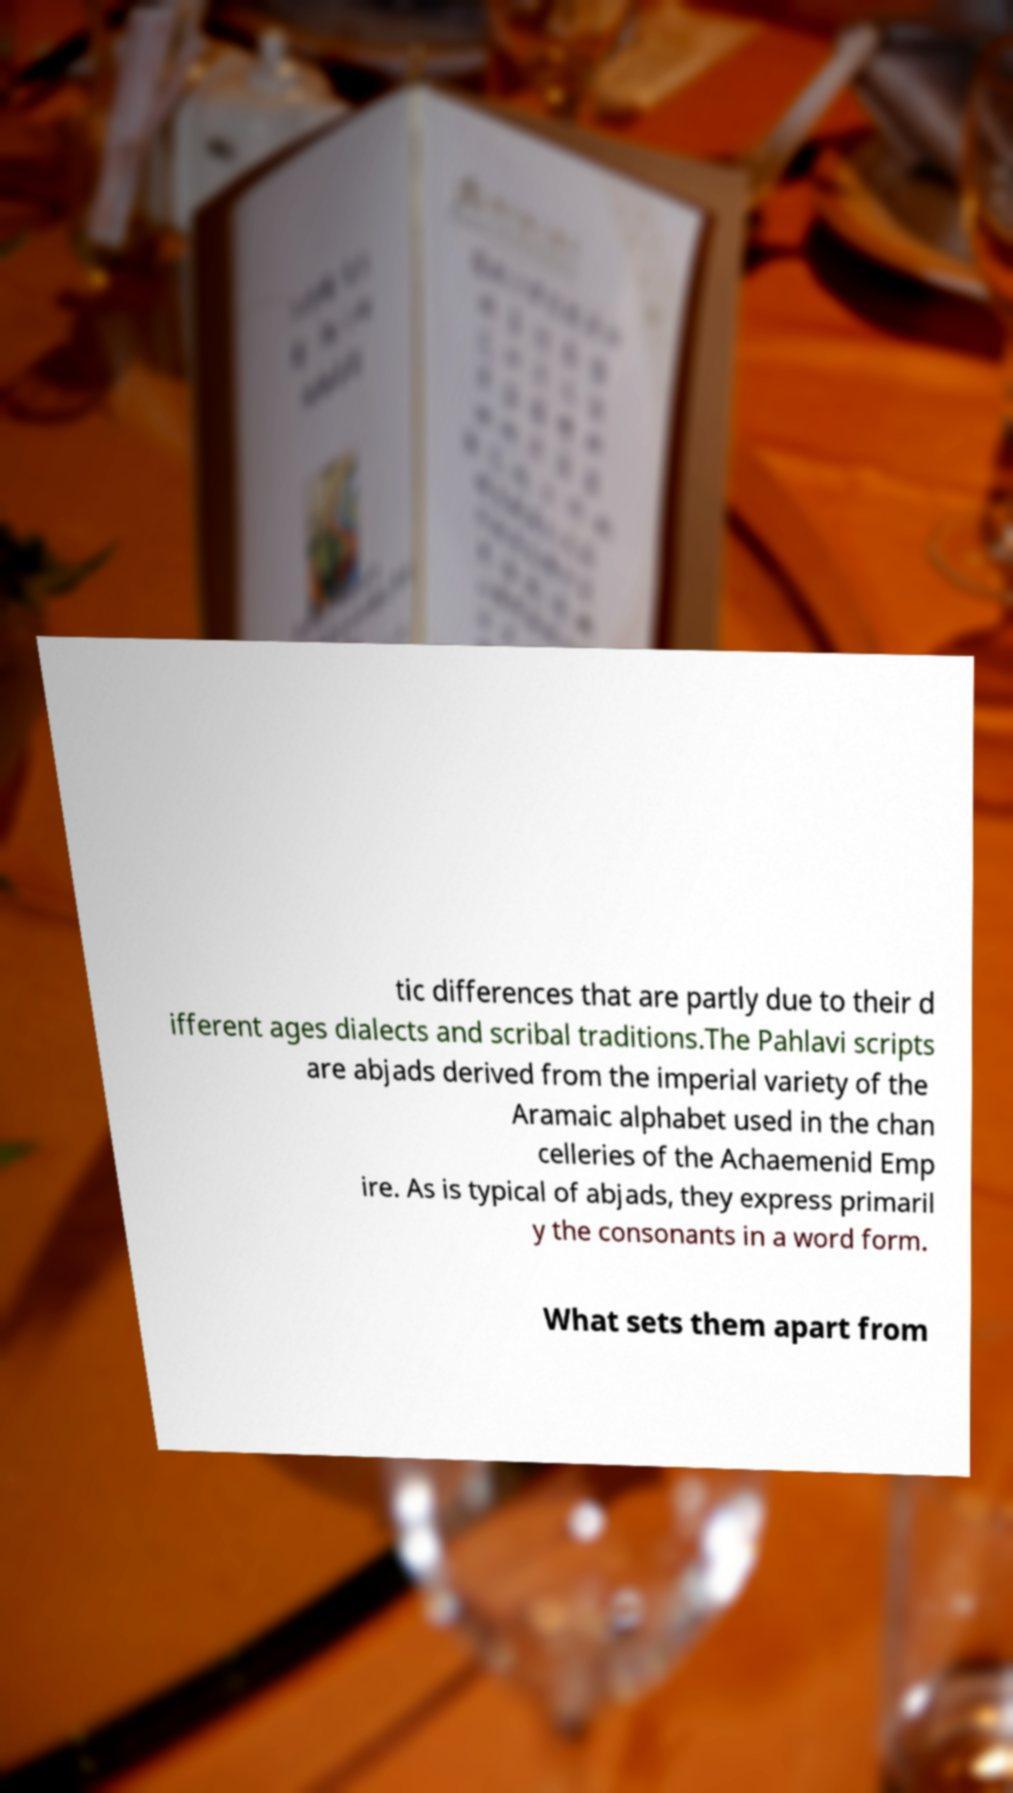Can you accurately transcribe the text from the provided image for me? tic differences that are partly due to their d ifferent ages dialects and scribal traditions.The Pahlavi scripts are abjads derived from the imperial variety of the Aramaic alphabet used in the chan celleries of the Achaemenid Emp ire. As is typical of abjads, they express primaril y the consonants in a word form. What sets them apart from 